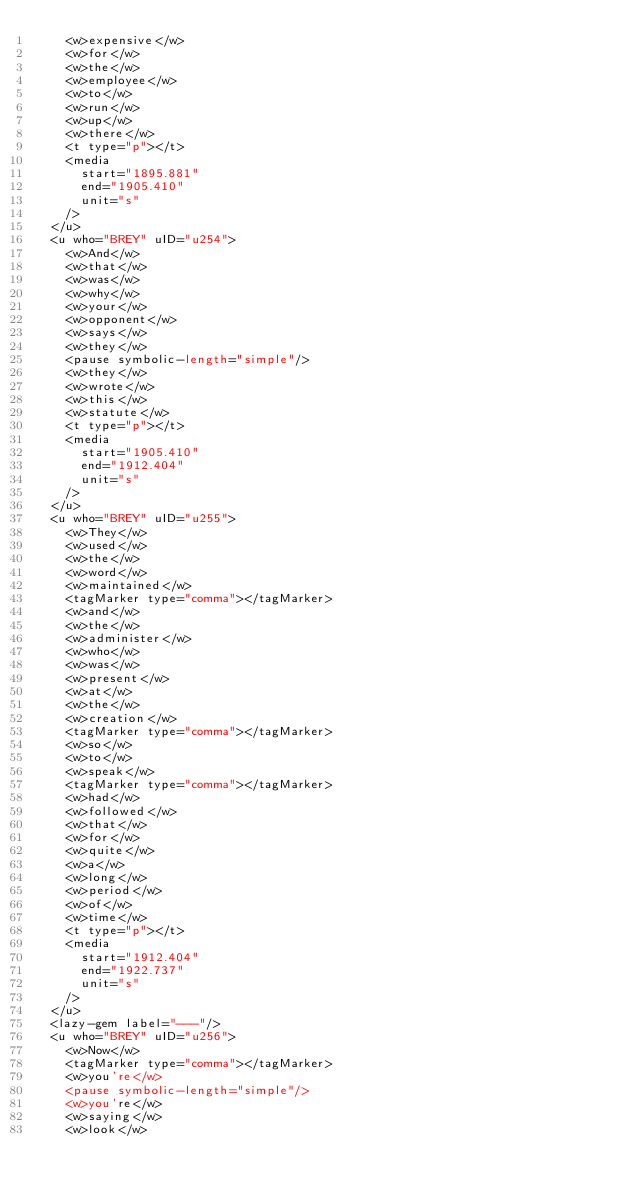Convert code to text. <code><loc_0><loc_0><loc_500><loc_500><_XML_>    <w>expensive</w>
    <w>for</w>
    <w>the</w>
    <w>employee</w>
    <w>to</w>
    <w>run</w>
    <w>up</w>
    <w>there</w>
    <t type="p"></t>
    <media
      start="1895.881"
      end="1905.410"
      unit="s"
    />
  </u>
  <u who="BREY" uID="u254">
    <w>And</w>
    <w>that</w>
    <w>was</w>
    <w>why</w>
    <w>your</w>
    <w>opponent</w>
    <w>says</w>
    <w>they</w>
    <pause symbolic-length="simple"/>
    <w>they</w>
    <w>wrote</w>
    <w>this</w>
    <w>statute</w>
    <t type="p"></t>
    <media
      start="1905.410"
      end="1912.404"
      unit="s"
    />
  </u>
  <u who="BREY" uID="u255">
    <w>They</w>
    <w>used</w>
    <w>the</w>
    <w>word</w>
    <w>maintained</w>
    <tagMarker type="comma"></tagMarker>
    <w>and</w>
    <w>the</w>
    <w>administer</w>
    <w>who</w>
    <w>was</w>
    <w>present</w>
    <w>at</w>
    <w>the</w>
    <w>creation</w>
    <tagMarker type="comma"></tagMarker>
    <w>so</w>
    <w>to</w>
    <w>speak</w>
    <tagMarker type="comma"></tagMarker>
    <w>had</w>
    <w>followed</w>
    <w>that</w>
    <w>for</w>
    <w>quite</w>
    <w>a</w>
    <w>long</w>
    <w>period</w>
    <w>of</w>
    <w>time</w>
    <t type="p"></t>
    <media
      start="1912.404"
      end="1922.737"
      unit="s"
    />
  </u>
  <lazy-gem label="---"/>
  <u who="BREY" uID="u256">
    <w>Now</w>
    <tagMarker type="comma"></tagMarker>
    <w>you're</w>
    <pause symbolic-length="simple"/>
    <w>you're</w>
    <w>saying</w>
    <w>look</w></code> 